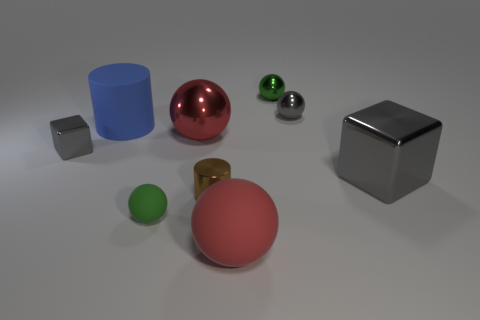The gray object that is in front of the big blue thing and right of the small gray metallic block is made of what material?
Your answer should be compact. Metal. What number of shiny things are the same shape as the big red matte object?
Provide a short and direct response. 3. What color is the block to the left of the small gray thing right of the large matte ball?
Your response must be concise. Gray. Is the number of rubber things behind the big gray metallic object the same as the number of objects?
Your answer should be very brief. No. Is there a gray shiny thing that has the same size as the blue object?
Give a very brief answer. Yes. Do the brown metallic cylinder and the metal cube right of the blue matte cylinder have the same size?
Provide a short and direct response. No. Are there an equal number of big cylinders that are right of the large red matte ball and big blue rubber cylinders that are in front of the metal cylinder?
Provide a succinct answer. Yes. What is the shape of the thing that is the same color as the large shiny sphere?
Ensure brevity in your answer.  Sphere. What is the tiny green sphere that is in front of the large gray thing made of?
Your answer should be very brief. Rubber. Is the size of the brown cylinder the same as the gray shiny ball?
Your answer should be very brief. Yes. 